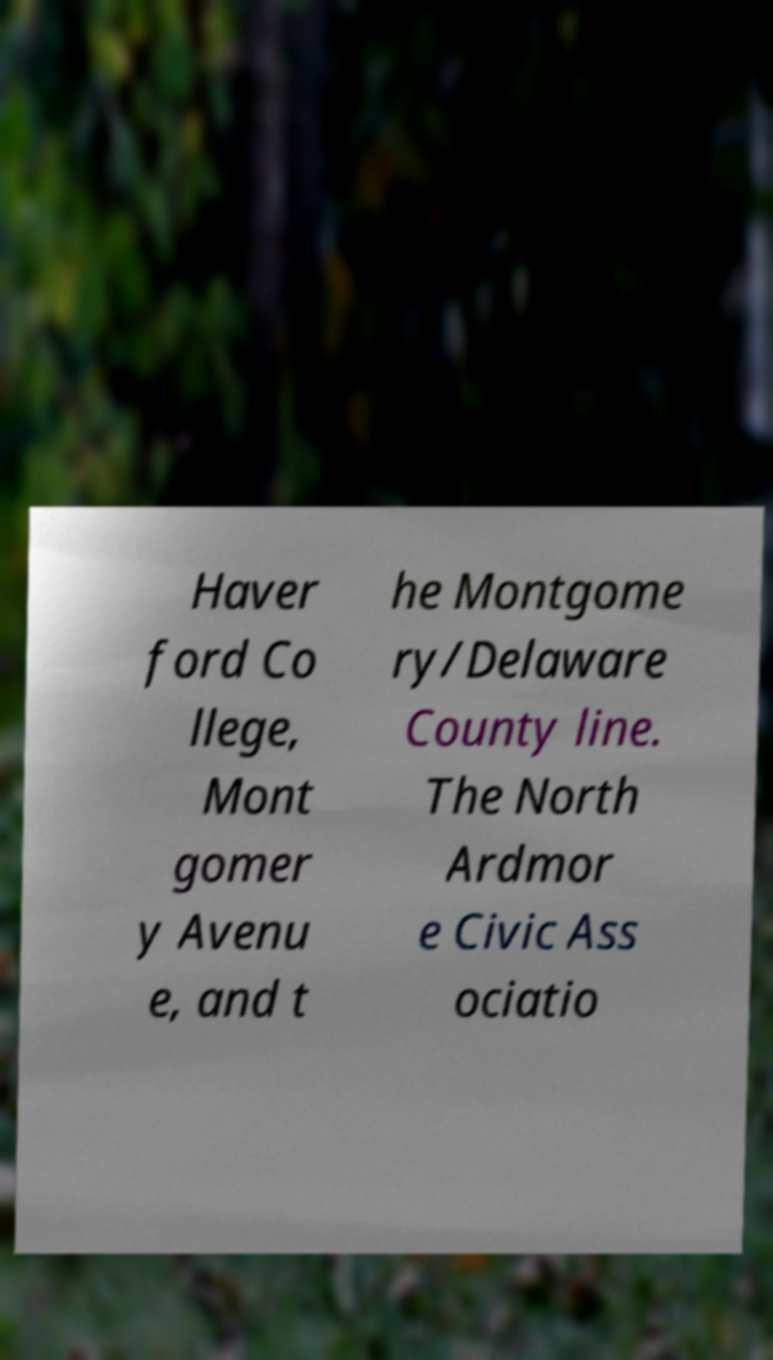Could you assist in decoding the text presented in this image and type it out clearly? Haver ford Co llege, Mont gomer y Avenu e, and t he Montgome ry/Delaware County line. The North Ardmor e Civic Ass ociatio 